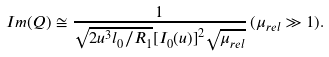Convert formula to latex. <formula><loc_0><loc_0><loc_500><loc_500>I m ( { Q } ) \cong \frac { 1 } { \sqrt { 2 u ^ { 3 } l _ { 0 } / R _ { 1 } } { [ { I } _ { 0 } ( u ) ] } ^ { 2 } \sqrt { { \mu } _ { r e l } } } \, ( { \mu } _ { r e l } \gg 1 ) .</formula> 